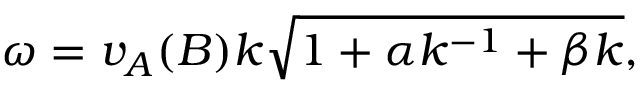Convert formula to latex. <formula><loc_0><loc_0><loc_500><loc_500>\omega = v _ { A } ( B ) k \sqrt { 1 + \alpha k ^ { - 1 } + \beta k } ,</formula> 